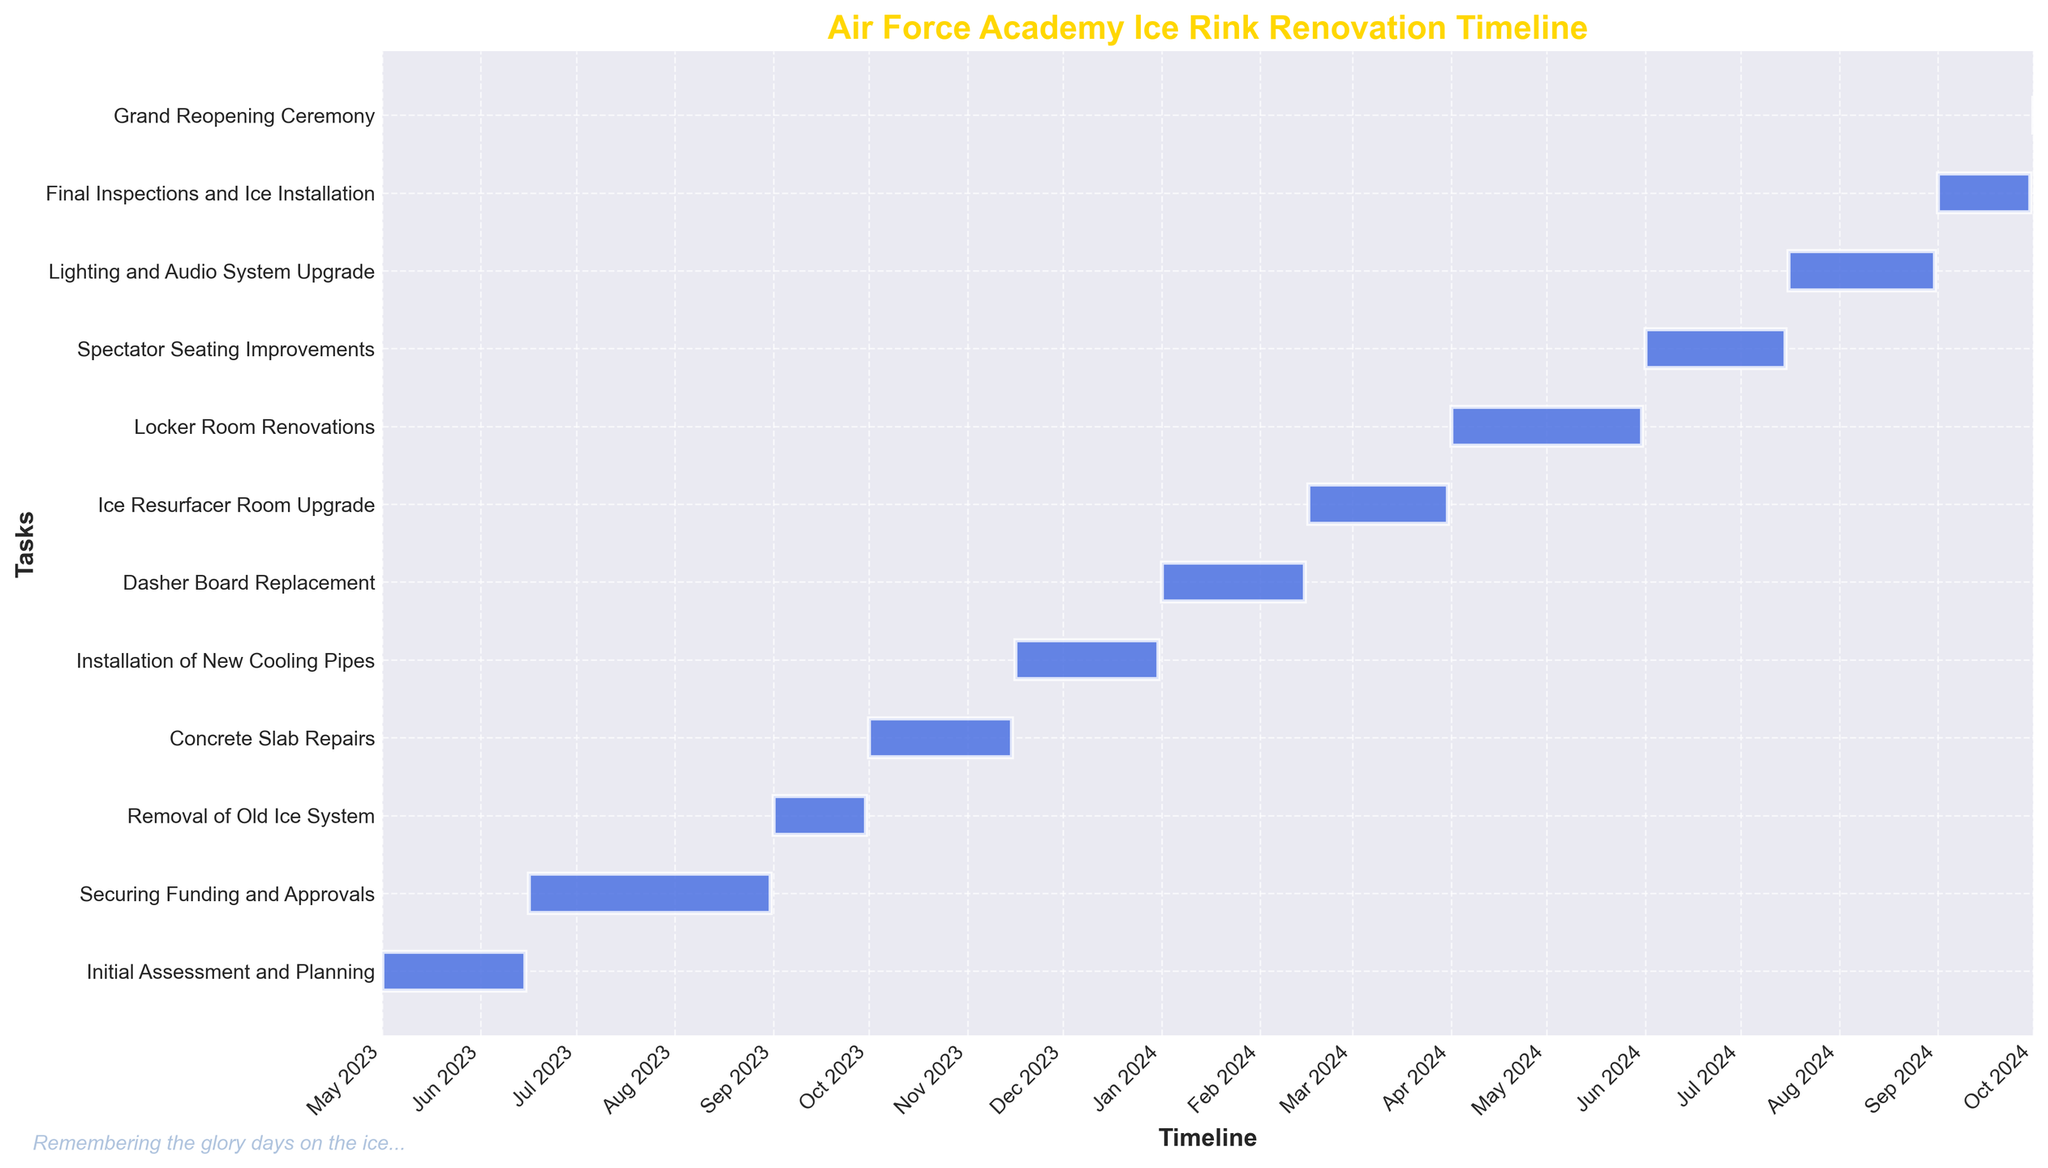What is the title of the figure? The title can be found at the top of the Gantt chart. It is typically bold and larger than other text elements, making it easy to identify.
Answer: Air Force Academy Ice Rink Renovation Timeline How many tasks are displayed in the timeline? Count the number of horizontal bars in the Gantt chart, each representing a separate task.
Answer: 11 During which month does the "Removal of Old Ice System" take place? Look for the "Removal of Old Ice System" task on the Y-axis and then trace horizontally to the corresponding month shown on the X-axis.
Answer: September 2023 Which task has the shortest duration? Compare the lengths of all the horizontal bars; the shortest bar represents the task with the shortest duration.
Answer: Grand Reopening Ceremony What's the average duration of the tasks in the timeline? First, calculate the duration of each task by subtracting the start date from the end date. Sum up these durations and then divide by the number of tasks to find the average.
Answer: (45 + 76 + 30 + 45 + 45 + 45 + 45 + 61 + 45 + 46 + 30) / 11 = 49.45 days Which tasks are active in January 2024? Identify the tasks whose bars cover the period from January 1, 2024, to January 31, 2024, by looking at which bars pass through this timeframe.
Answer: Dasher Board Replacement How long after the start of "Installation of New Cooling Pipes" does "Dasher Board Replacement" begin? Note the start dates of both tasks and calculate the difference in days between the start of "Dasher Board Replacement" and the start of "Installation of New Cooling Pipes".
Answer: 46 days Which task is completed first: "Spectator Seating Improvements" or "Lighting and Audio System Upgrade"? Compare the end dates of "Spectator Seating Improvements" and "Lighting and Audio System Upgrade" to see which one comes first chronologically.
Answer: Spectator Seating Improvements How does the duration of "Locker Room Renovations" compare with "Concrete Slab Repairs"? Calculate and compare the duration of both tasks by subtracting the start dates from the end dates for each task.
Answer: Locker Room Renovations are 15 days longer What tasks coincide with "Final Inspections and Ice Installation"? Determine which bars overlap with the duration of "Final Inspections and Ice Installation" by checking the overlap period visually on the Gantt chart.
Answer: No tasks coincide 